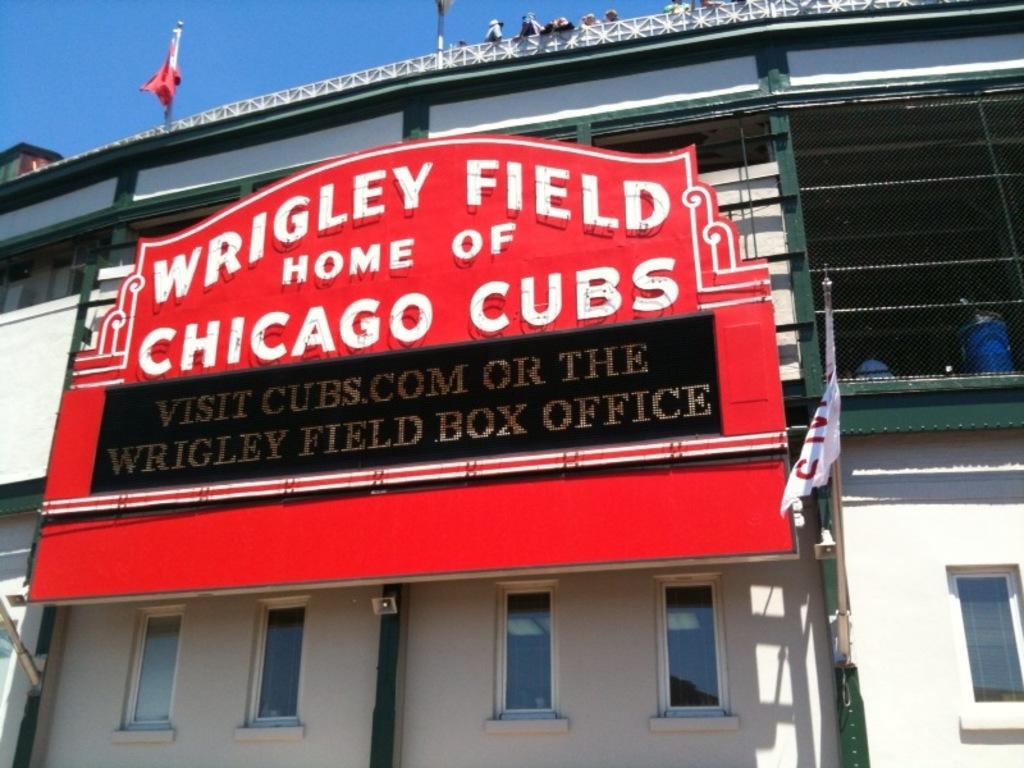Could you give a brief overview of what you see in this image? In this image I can see a building which is white and green in color, a huge board to the building which is red, black and white in color and few flags. I can see few windows of the building and in the background I can see the sky. 